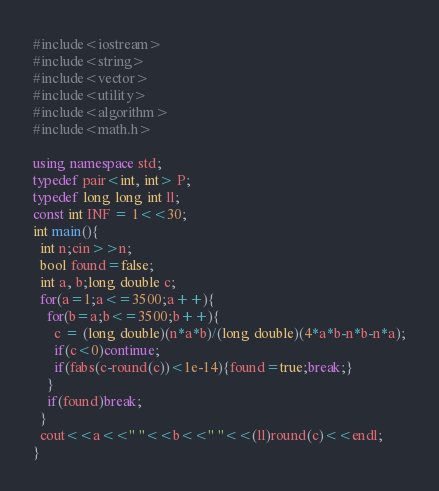Convert code to text. <code><loc_0><loc_0><loc_500><loc_500><_C++_>#include<iostream>
#include<string>
#include<vector>
#include<utility>
#include<algorithm>
#include<math.h>

using namespace std;
typedef pair<int, int> P;
typedef long long int ll;
const int INF = 1<<30;
int main(){
  int n;cin>>n;
  bool found=false;
  int a, b;long double c;
  for(a=1;a<=3500;a++){
    for(b=a;b<=3500;b++){
      c = (long double)(n*a*b)/(long double)(4*a*b-n*b-n*a);
      if(c<0)continue;
      if(fabs(c-round(c))<1e-14){found=true;break;}
    }
    if(found)break;
  }
  cout<<a<<" "<<b<<" "<<(ll)round(c)<<endl;
}
</code> 